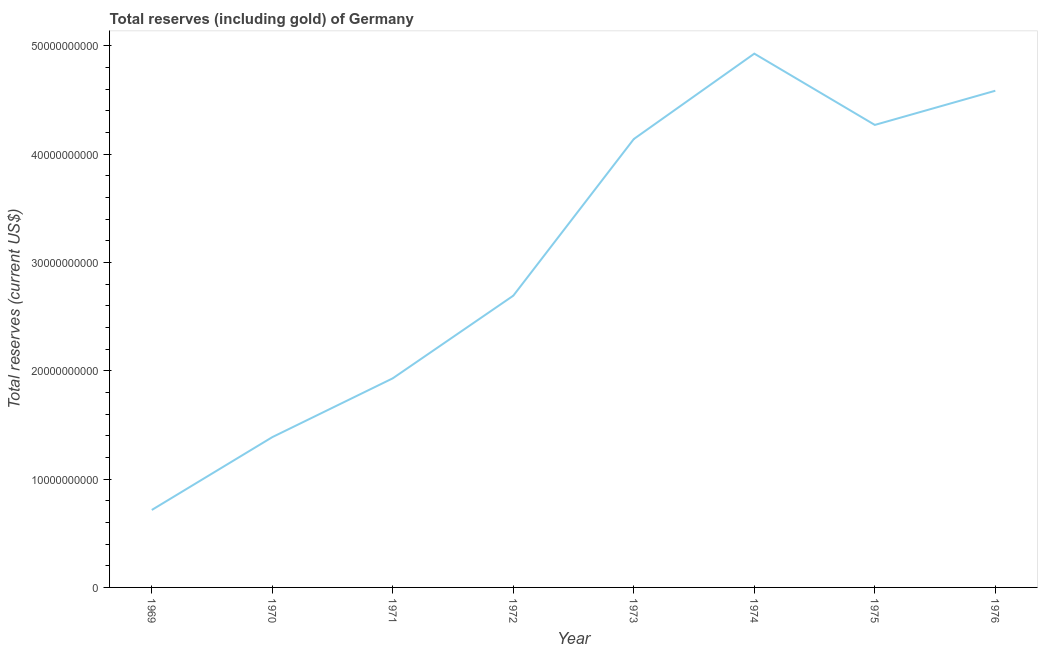What is the total reserves (including gold) in 1974?
Your response must be concise. 4.93e+1. Across all years, what is the maximum total reserves (including gold)?
Give a very brief answer. 4.93e+1. Across all years, what is the minimum total reserves (including gold)?
Your response must be concise. 7.15e+09. In which year was the total reserves (including gold) maximum?
Provide a succinct answer. 1974. In which year was the total reserves (including gold) minimum?
Give a very brief answer. 1969. What is the sum of the total reserves (including gold)?
Ensure brevity in your answer.  2.47e+11. What is the difference between the total reserves (including gold) in 1973 and 1975?
Your response must be concise. -1.30e+09. What is the average total reserves (including gold) per year?
Your response must be concise. 3.08e+1. What is the median total reserves (including gold)?
Offer a very short reply. 3.42e+1. In how many years, is the total reserves (including gold) greater than 10000000000 US$?
Provide a succinct answer. 7. What is the ratio of the total reserves (including gold) in 1974 to that in 1975?
Your answer should be compact. 1.15. Is the difference between the total reserves (including gold) in 1973 and 1975 greater than the difference between any two years?
Give a very brief answer. No. What is the difference between the highest and the second highest total reserves (including gold)?
Your response must be concise. 3.43e+09. Is the sum of the total reserves (including gold) in 1971 and 1975 greater than the maximum total reserves (including gold) across all years?
Ensure brevity in your answer.  Yes. What is the difference between the highest and the lowest total reserves (including gold)?
Offer a terse response. 4.21e+1. How many years are there in the graph?
Offer a very short reply. 8. Does the graph contain any zero values?
Your response must be concise. No. Does the graph contain grids?
Offer a very short reply. No. What is the title of the graph?
Keep it short and to the point. Total reserves (including gold) of Germany. What is the label or title of the Y-axis?
Provide a succinct answer. Total reserves (current US$). What is the Total reserves (current US$) in 1969?
Make the answer very short. 7.15e+09. What is the Total reserves (current US$) in 1970?
Make the answer very short. 1.39e+1. What is the Total reserves (current US$) of 1971?
Keep it short and to the point. 1.93e+1. What is the Total reserves (current US$) in 1972?
Offer a very short reply. 2.69e+1. What is the Total reserves (current US$) in 1973?
Make the answer very short. 4.14e+1. What is the Total reserves (current US$) in 1974?
Provide a short and direct response. 4.93e+1. What is the Total reserves (current US$) in 1975?
Provide a short and direct response. 4.27e+1. What is the Total reserves (current US$) in 1976?
Your response must be concise. 4.59e+1. What is the difference between the Total reserves (current US$) in 1969 and 1970?
Keep it short and to the point. -6.73e+09. What is the difference between the Total reserves (current US$) in 1969 and 1971?
Ensure brevity in your answer.  -1.22e+1. What is the difference between the Total reserves (current US$) in 1969 and 1972?
Make the answer very short. -1.98e+1. What is the difference between the Total reserves (current US$) in 1969 and 1973?
Your answer should be compact. -3.43e+1. What is the difference between the Total reserves (current US$) in 1969 and 1974?
Your response must be concise. -4.21e+1. What is the difference between the Total reserves (current US$) in 1969 and 1975?
Your answer should be compact. -3.56e+1. What is the difference between the Total reserves (current US$) in 1969 and 1976?
Keep it short and to the point. -3.87e+1. What is the difference between the Total reserves (current US$) in 1970 and 1971?
Your answer should be compact. -5.43e+09. What is the difference between the Total reserves (current US$) in 1970 and 1972?
Your response must be concise. -1.31e+1. What is the difference between the Total reserves (current US$) in 1970 and 1973?
Make the answer very short. -2.75e+1. What is the difference between the Total reserves (current US$) in 1970 and 1974?
Give a very brief answer. -3.54e+1. What is the difference between the Total reserves (current US$) in 1970 and 1975?
Ensure brevity in your answer.  -2.88e+1. What is the difference between the Total reserves (current US$) in 1970 and 1976?
Your answer should be very brief. -3.20e+1. What is the difference between the Total reserves (current US$) in 1971 and 1972?
Give a very brief answer. -7.63e+09. What is the difference between the Total reserves (current US$) in 1971 and 1973?
Offer a very short reply. -2.21e+1. What is the difference between the Total reserves (current US$) in 1971 and 1974?
Ensure brevity in your answer.  -3.00e+1. What is the difference between the Total reserves (current US$) in 1971 and 1975?
Ensure brevity in your answer.  -2.34e+1. What is the difference between the Total reserves (current US$) in 1971 and 1976?
Your answer should be very brief. -2.66e+1. What is the difference between the Total reserves (current US$) in 1972 and 1973?
Give a very brief answer. -1.45e+1. What is the difference between the Total reserves (current US$) in 1972 and 1974?
Provide a succinct answer. -2.24e+1. What is the difference between the Total reserves (current US$) in 1972 and 1975?
Provide a succinct answer. -1.58e+1. What is the difference between the Total reserves (current US$) in 1972 and 1976?
Provide a succinct answer. -1.89e+1. What is the difference between the Total reserves (current US$) in 1973 and 1974?
Offer a terse response. -7.89e+09. What is the difference between the Total reserves (current US$) in 1973 and 1975?
Provide a succinct answer. -1.30e+09. What is the difference between the Total reserves (current US$) in 1973 and 1976?
Your response must be concise. -4.46e+09. What is the difference between the Total reserves (current US$) in 1974 and 1975?
Make the answer very short. 6.58e+09. What is the difference between the Total reserves (current US$) in 1974 and 1976?
Your answer should be very brief. 3.43e+09. What is the difference between the Total reserves (current US$) in 1975 and 1976?
Provide a short and direct response. -3.16e+09. What is the ratio of the Total reserves (current US$) in 1969 to that in 1970?
Keep it short and to the point. 0.52. What is the ratio of the Total reserves (current US$) in 1969 to that in 1971?
Offer a terse response. 0.37. What is the ratio of the Total reserves (current US$) in 1969 to that in 1972?
Your response must be concise. 0.27. What is the ratio of the Total reserves (current US$) in 1969 to that in 1973?
Provide a short and direct response. 0.17. What is the ratio of the Total reserves (current US$) in 1969 to that in 1974?
Your answer should be compact. 0.14. What is the ratio of the Total reserves (current US$) in 1969 to that in 1975?
Give a very brief answer. 0.17. What is the ratio of the Total reserves (current US$) in 1969 to that in 1976?
Offer a very short reply. 0.16. What is the ratio of the Total reserves (current US$) in 1970 to that in 1971?
Keep it short and to the point. 0.72. What is the ratio of the Total reserves (current US$) in 1970 to that in 1972?
Make the answer very short. 0.52. What is the ratio of the Total reserves (current US$) in 1970 to that in 1973?
Your answer should be compact. 0.34. What is the ratio of the Total reserves (current US$) in 1970 to that in 1974?
Provide a succinct answer. 0.28. What is the ratio of the Total reserves (current US$) in 1970 to that in 1975?
Give a very brief answer. 0.33. What is the ratio of the Total reserves (current US$) in 1970 to that in 1976?
Provide a short and direct response. 0.3. What is the ratio of the Total reserves (current US$) in 1971 to that in 1972?
Ensure brevity in your answer.  0.72. What is the ratio of the Total reserves (current US$) in 1971 to that in 1973?
Offer a very short reply. 0.47. What is the ratio of the Total reserves (current US$) in 1971 to that in 1974?
Give a very brief answer. 0.39. What is the ratio of the Total reserves (current US$) in 1971 to that in 1975?
Offer a terse response. 0.45. What is the ratio of the Total reserves (current US$) in 1971 to that in 1976?
Ensure brevity in your answer.  0.42. What is the ratio of the Total reserves (current US$) in 1972 to that in 1973?
Ensure brevity in your answer.  0.65. What is the ratio of the Total reserves (current US$) in 1972 to that in 1974?
Make the answer very short. 0.55. What is the ratio of the Total reserves (current US$) in 1972 to that in 1975?
Offer a terse response. 0.63. What is the ratio of the Total reserves (current US$) in 1972 to that in 1976?
Offer a very short reply. 0.59. What is the ratio of the Total reserves (current US$) in 1973 to that in 1974?
Keep it short and to the point. 0.84. What is the ratio of the Total reserves (current US$) in 1973 to that in 1976?
Your answer should be compact. 0.9. What is the ratio of the Total reserves (current US$) in 1974 to that in 1975?
Your answer should be compact. 1.15. What is the ratio of the Total reserves (current US$) in 1974 to that in 1976?
Offer a very short reply. 1.07. 